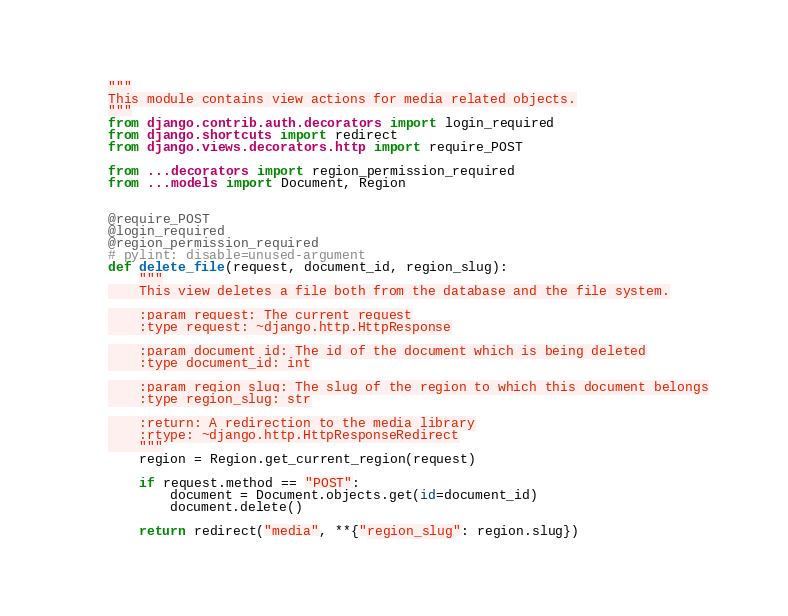<code> <loc_0><loc_0><loc_500><loc_500><_Python_>"""
This module contains view actions for media related objects.
"""
from django.contrib.auth.decorators import login_required
from django.shortcuts import redirect
from django.views.decorators.http import require_POST

from ...decorators import region_permission_required
from ...models import Document, Region


@require_POST
@login_required
@region_permission_required
# pylint: disable=unused-argument
def delete_file(request, document_id, region_slug):
    """
    This view deletes a file both from the database and the file system.

    :param request: The current request
    :type request: ~django.http.HttpResponse

    :param document_id: The id of the document which is being deleted
    :type document_id: int

    :param region_slug: The slug of the region to which this document belongs
    :type region_slug: str

    :return: A redirection to the media library
    :rtype: ~django.http.HttpResponseRedirect
    """
    region = Region.get_current_region(request)

    if request.method == "POST":
        document = Document.objects.get(id=document_id)
        document.delete()

    return redirect("media", **{"region_slug": region.slug})
</code> 